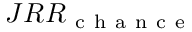<formula> <loc_0><loc_0><loc_500><loc_500>J R R _ { c h a n c e }</formula> 